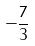Convert formula to latex. <formula><loc_0><loc_0><loc_500><loc_500>- \frac { 7 } { 3 }</formula> 